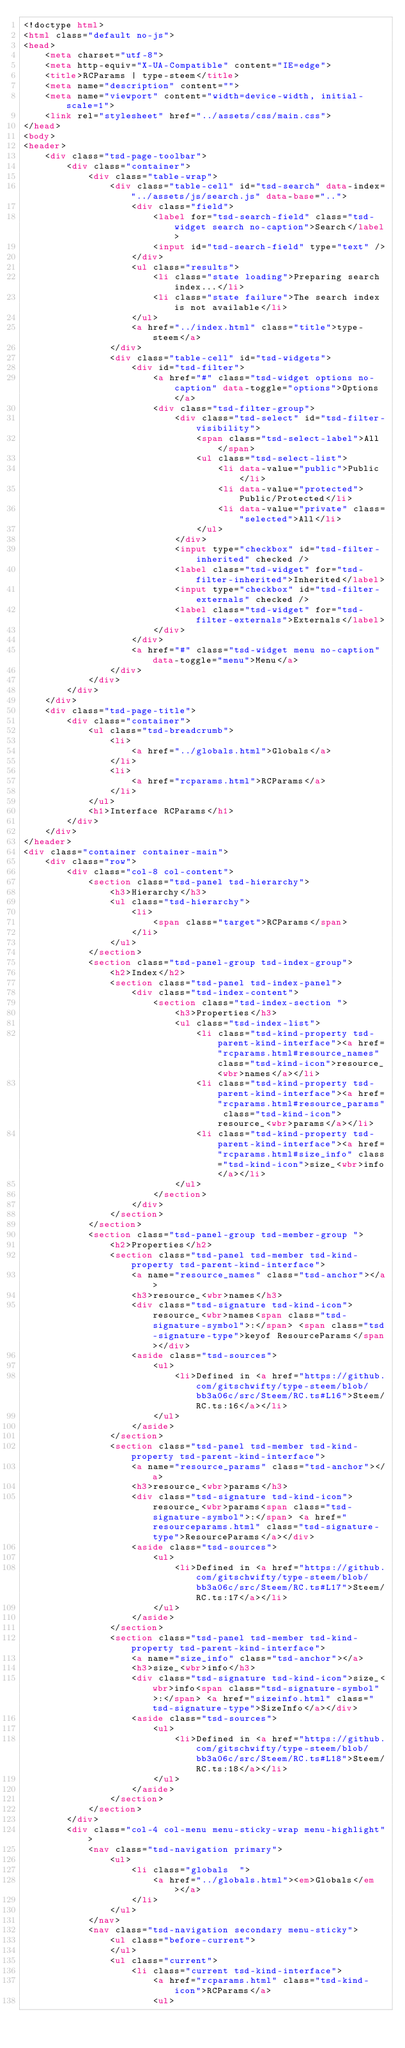Convert code to text. <code><loc_0><loc_0><loc_500><loc_500><_HTML_><!doctype html>
<html class="default no-js">
<head>
	<meta charset="utf-8">
	<meta http-equiv="X-UA-Compatible" content="IE=edge">
	<title>RCParams | type-steem</title>
	<meta name="description" content="">
	<meta name="viewport" content="width=device-width, initial-scale=1">
	<link rel="stylesheet" href="../assets/css/main.css">
</head>
<body>
<header>
	<div class="tsd-page-toolbar">
		<div class="container">
			<div class="table-wrap">
				<div class="table-cell" id="tsd-search" data-index="../assets/js/search.js" data-base="..">
					<div class="field">
						<label for="tsd-search-field" class="tsd-widget search no-caption">Search</label>
						<input id="tsd-search-field" type="text" />
					</div>
					<ul class="results">
						<li class="state loading">Preparing search index...</li>
						<li class="state failure">The search index is not available</li>
					</ul>
					<a href="../index.html" class="title">type-steem</a>
				</div>
				<div class="table-cell" id="tsd-widgets">
					<div id="tsd-filter">
						<a href="#" class="tsd-widget options no-caption" data-toggle="options">Options</a>
						<div class="tsd-filter-group">
							<div class="tsd-select" id="tsd-filter-visibility">
								<span class="tsd-select-label">All</span>
								<ul class="tsd-select-list">
									<li data-value="public">Public</li>
									<li data-value="protected">Public/Protected</li>
									<li data-value="private" class="selected">All</li>
								</ul>
							</div>
							<input type="checkbox" id="tsd-filter-inherited" checked />
							<label class="tsd-widget" for="tsd-filter-inherited">Inherited</label>
							<input type="checkbox" id="tsd-filter-externals" checked />
							<label class="tsd-widget" for="tsd-filter-externals">Externals</label>
						</div>
					</div>
					<a href="#" class="tsd-widget menu no-caption" data-toggle="menu">Menu</a>
				</div>
			</div>
		</div>
	</div>
	<div class="tsd-page-title">
		<div class="container">
			<ul class="tsd-breadcrumb">
				<li>
					<a href="../globals.html">Globals</a>
				</li>
				<li>
					<a href="rcparams.html">RCParams</a>
				</li>
			</ul>
			<h1>Interface RCParams</h1>
		</div>
	</div>
</header>
<div class="container container-main">
	<div class="row">
		<div class="col-8 col-content">
			<section class="tsd-panel tsd-hierarchy">
				<h3>Hierarchy</h3>
				<ul class="tsd-hierarchy">
					<li>
						<span class="target">RCParams</span>
					</li>
				</ul>
			</section>
			<section class="tsd-panel-group tsd-index-group">
				<h2>Index</h2>
				<section class="tsd-panel tsd-index-panel">
					<div class="tsd-index-content">
						<section class="tsd-index-section ">
							<h3>Properties</h3>
							<ul class="tsd-index-list">
								<li class="tsd-kind-property tsd-parent-kind-interface"><a href="rcparams.html#resource_names" class="tsd-kind-icon">resource_<wbr>names</a></li>
								<li class="tsd-kind-property tsd-parent-kind-interface"><a href="rcparams.html#resource_params" class="tsd-kind-icon">resource_<wbr>params</a></li>
								<li class="tsd-kind-property tsd-parent-kind-interface"><a href="rcparams.html#size_info" class="tsd-kind-icon">size_<wbr>info</a></li>
							</ul>
						</section>
					</div>
				</section>
			</section>
			<section class="tsd-panel-group tsd-member-group ">
				<h2>Properties</h2>
				<section class="tsd-panel tsd-member tsd-kind-property tsd-parent-kind-interface">
					<a name="resource_names" class="tsd-anchor"></a>
					<h3>resource_<wbr>names</h3>
					<div class="tsd-signature tsd-kind-icon">resource_<wbr>names<span class="tsd-signature-symbol">:</span> <span class="tsd-signature-type">keyof ResourceParams</span></div>
					<aside class="tsd-sources">
						<ul>
							<li>Defined in <a href="https://github.com/gitschwifty/type-steem/blob/bb3a06c/src/Steem/RC.ts#L16">Steem/RC.ts:16</a></li>
						</ul>
					</aside>
				</section>
				<section class="tsd-panel tsd-member tsd-kind-property tsd-parent-kind-interface">
					<a name="resource_params" class="tsd-anchor"></a>
					<h3>resource_<wbr>params</h3>
					<div class="tsd-signature tsd-kind-icon">resource_<wbr>params<span class="tsd-signature-symbol">:</span> <a href="resourceparams.html" class="tsd-signature-type">ResourceParams</a></div>
					<aside class="tsd-sources">
						<ul>
							<li>Defined in <a href="https://github.com/gitschwifty/type-steem/blob/bb3a06c/src/Steem/RC.ts#L17">Steem/RC.ts:17</a></li>
						</ul>
					</aside>
				</section>
				<section class="tsd-panel tsd-member tsd-kind-property tsd-parent-kind-interface">
					<a name="size_info" class="tsd-anchor"></a>
					<h3>size_<wbr>info</h3>
					<div class="tsd-signature tsd-kind-icon">size_<wbr>info<span class="tsd-signature-symbol">:</span> <a href="sizeinfo.html" class="tsd-signature-type">SizeInfo</a></div>
					<aside class="tsd-sources">
						<ul>
							<li>Defined in <a href="https://github.com/gitschwifty/type-steem/blob/bb3a06c/src/Steem/RC.ts#L18">Steem/RC.ts:18</a></li>
						</ul>
					</aside>
				</section>
			</section>
		</div>
		<div class="col-4 col-menu menu-sticky-wrap menu-highlight">
			<nav class="tsd-navigation primary">
				<ul>
					<li class="globals  ">
						<a href="../globals.html"><em>Globals</em></a>
					</li>
				</ul>
			</nav>
			<nav class="tsd-navigation secondary menu-sticky">
				<ul class="before-current">
				</ul>
				<ul class="current">
					<li class="current tsd-kind-interface">
						<a href="rcparams.html" class="tsd-kind-icon">RCParams</a>
						<ul></code> 